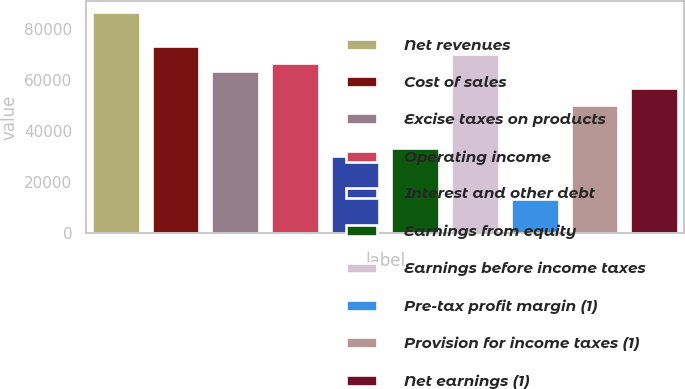Convert chart to OTSL. <chart><loc_0><loc_0><loc_500><loc_500><bar_chart><fcel>Net revenues<fcel>Cost of sales<fcel>Excise taxes on products<fcel>Operating income<fcel>Interest and other debt<fcel>Earnings from equity<fcel>Earnings before income taxes<fcel>Pre-tax profit margin (1)<fcel>Provision for income taxes (1)<fcel>Net earnings (1)<nl><fcel>86941.6<fcel>73566.2<fcel>63534.7<fcel>66878.5<fcel>30096.2<fcel>33440<fcel>70222.4<fcel>13376.9<fcel>50159.3<fcel>56847<nl></chart> 